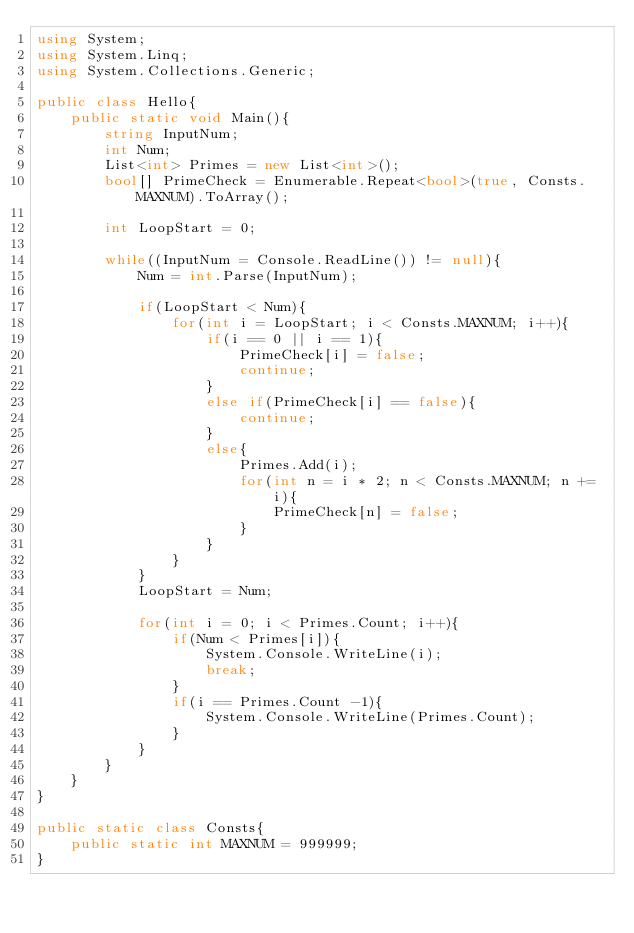<code> <loc_0><loc_0><loc_500><loc_500><_C#_>using System;
using System.Linq;
using System.Collections.Generic;

public class Hello{
    public static void Main(){
        string InputNum;
        int Num;
        List<int> Primes = new List<int>();
        bool[] PrimeCheck = Enumerable.Repeat<bool>(true, Consts.MAXNUM).ToArray();
        
        int LoopStart = 0;
        
        while((InputNum = Console.ReadLine()) != null){
            Num = int.Parse(InputNum);

            if(LoopStart < Num){
                for(int i = LoopStart; i < Consts.MAXNUM; i++){
                    if(i == 0 || i == 1){
                        PrimeCheck[i] = false;
                        continue;
                    }
                    else if(PrimeCheck[i] == false){
                        continue;
                    }
                    else{
                        Primes.Add(i);
                        for(int n = i * 2; n < Consts.MAXNUM; n += i){
                            PrimeCheck[n] = false;
                        }
                    }
                }
            }
            LoopStart = Num;
            
            for(int i = 0; i < Primes.Count; i++){
                if(Num < Primes[i]){
                    System.Console.WriteLine(i);
                    break;
                }
                if(i == Primes.Count -1){
                    System.Console.WriteLine(Primes.Count);
                }
            }
        }
    }
}

public static class Consts{
    public static int MAXNUM = 999999;
}</code> 